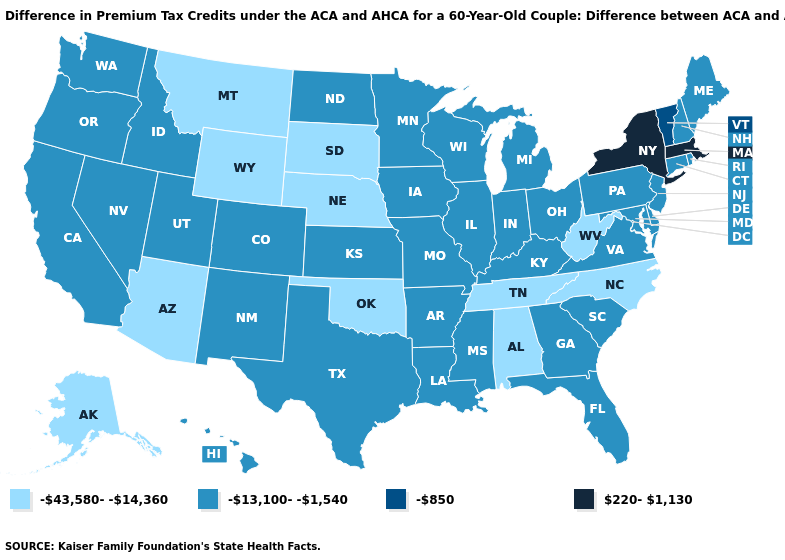Which states have the lowest value in the USA?
Concise answer only. Alabama, Alaska, Arizona, Montana, Nebraska, North Carolina, Oklahoma, South Dakota, Tennessee, West Virginia, Wyoming. Name the states that have a value in the range -13,100--1,540?
Quick response, please. Arkansas, California, Colorado, Connecticut, Delaware, Florida, Georgia, Hawaii, Idaho, Illinois, Indiana, Iowa, Kansas, Kentucky, Louisiana, Maine, Maryland, Michigan, Minnesota, Mississippi, Missouri, Nevada, New Hampshire, New Jersey, New Mexico, North Dakota, Ohio, Oregon, Pennsylvania, Rhode Island, South Carolina, Texas, Utah, Virginia, Washington, Wisconsin. Does New York have the same value as Kansas?
Write a very short answer. No. What is the lowest value in states that border Mississippi?
Quick response, please. -43,580--14,360. Name the states that have a value in the range -43,580--14,360?
Answer briefly. Alabama, Alaska, Arizona, Montana, Nebraska, North Carolina, Oklahoma, South Dakota, Tennessee, West Virginia, Wyoming. Does the first symbol in the legend represent the smallest category?
Write a very short answer. Yes. Name the states that have a value in the range -13,100--1,540?
Be succinct. Arkansas, California, Colorado, Connecticut, Delaware, Florida, Georgia, Hawaii, Idaho, Illinois, Indiana, Iowa, Kansas, Kentucky, Louisiana, Maine, Maryland, Michigan, Minnesota, Mississippi, Missouri, Nevada, New Hampshire, New Jersey, New Mexico, North Dakota, Ohio, Oregon, Pennsylvania, Rhode Island, South Carolina, Texas, Utah, Virginia, Washington, Wisconsin. Is the legend a continuous bar?
Answer briefly. No. Which states have the highest value in the USA?
Short answer required. Massachusetts, New York. Name the states that have a value in the range -850?
Write a very short answer. Vermont. Does the first symbol in the legend represent the smallest category?
Give a very brief answer. Yes. Does the map have missing data?
Concise answer only. No. What is the highest value in states that border Georgia?
Give a very brief answer. -13,100--1,540. Which states have the lowest value in the Northeast?
Short answer required. Connecticut, Maine, New Hampshire, New Jersey, Pennsylvania, Rhode Island. 